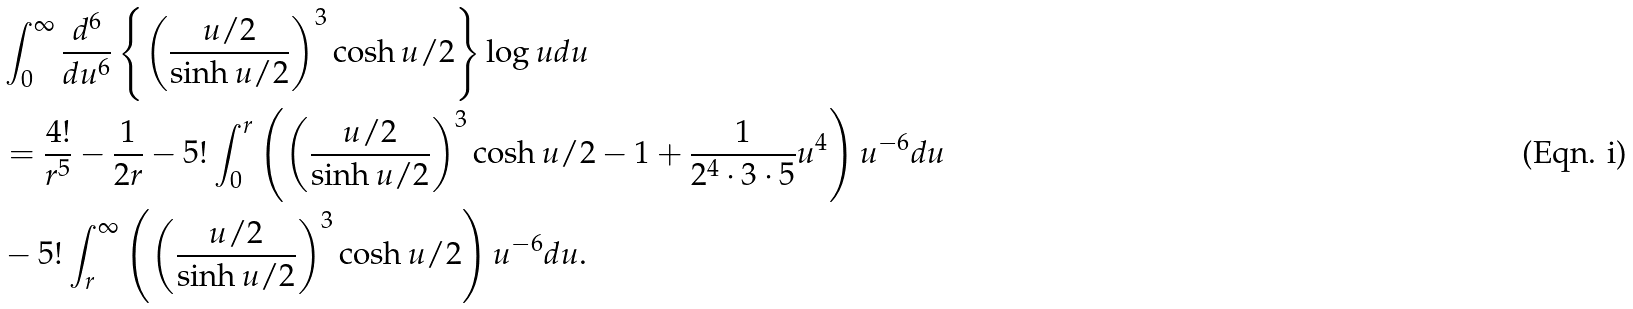<formula> <loc_0><loc_0><loc_500><loc_500>& \int _ { 0 } ^ { \infty } \frac { d ^ { 6 } } { d u ^ { 6 } } \left \{ \left ( \frac { u / 2 } { \sinh u / 2 } \right ) ^ { 3 } \cosh u / 2 \right \} \log u d u \\ & = \frac { 4 ! } { r ^ { 5 } } - \frac { 1 } { 2 r } - 5 ! \int _ { 0 } ^ { r } \left ( \left ( \frac { u / 2 } { \sinh u / 2 } \right ) ^ { 3 } \cosh u / 2 - 1 + \frac { 1 } { 2 ^ { 4 } \cdot 3 \cdot 5 } u ^ { 4 } \right ) u ^ { - 6 } d u \\ & - 5 ! \int _ { r } ^ { \infty } \left ( \left ( \frac { u / 2 } { \sinh u / 2 } \right ) ^ { 3 } \cosh u / 2 \right ) u ^ { - 6 } d u .</formula> 